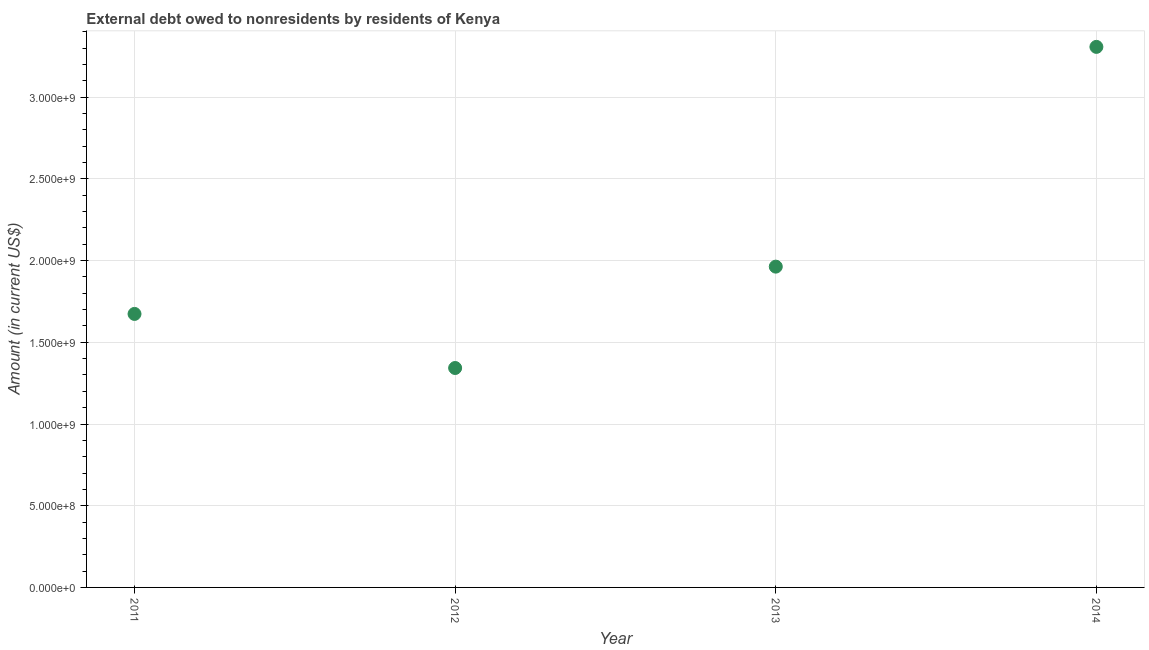What is the debt in 2011?
Your response must be concise. 1.67e+09. Across all years, what is the maximum debt?
Provide a short and direct response. 3.31e+09. Across all years, what is the minimum debt?
Your response must be concise. 1.34e+09. In which year was the debt minimum?
Provide a succinct answer. 2012. What is the sum of the debt?
Offer a terse response. 8.29e+09. What is the difference between the debt in 2011 and 2014?
Offer a very short reply. -1.63e+09. What is the average debt per year?
Your answer should be compact. 2.07e+09. What is the median debt?
Your answer should be very brief. 1.82e+09. In how many years, is the debt greater than 1400000000 US$?
Provide a short and direct response. 3. Do a majority of the years between 2011 and 2014 (inclusive) have debt greater than 3300000000 US$?
Your response must be concise. No. What is the ratio of the debt in 2011 to that in 2013?
Ensure brevity in your answer.  0.85. Is the debt in 2012 less than that in 2014?
Provide a short and direct response. Yes. What is the difference between the highest and the second highest debt?
Give a very brief answer. 1.34e+09. What is the difference between the highest and the lowest debt?
Your answer should be compact. 1.97e+09. In how many years, is the debt greater than the average debt taken over all years?
Your answer should be very brief. 1. What is the difference between two consecutive major ticks on the Y-axis?
Give a very brief answer. 5.00e+08. Are the values on the major ticks of Y-axis written in scientific E-notation?
Your response must be concise. Yes. Does the graph contain any zero values?
Provide a short and direct response. No. Does the graph contain grids?
Ensure brevity in your answer.  Yes. What is the title of the graph?
Keep it short and to the point. External debt owed to nonresidents by residents of Kenya. What is the label or title of the Y-axis?
Your answer should be very brief. Amount (in current US$). What is the Amount (in current US$) in 2011?
Offer a very short reply. 1.67e+09. What is the Amount (in current US$) in 2012?
Offer a terse response. 1.34e+09. What is the Amount (in current US$) in 2013?
Keep it short and to the point. 1.96e+09. What is the Amount (in current US$) in 2014?
Ensure brevity in your answer.  3.31e+09. What is the difference between the Amount (in current US$) in 2011 and 2012?
Offer a terse response. 3.31e+08. What is the difference between the Amount (in current US$) in 2011 and 2013?
Keep it short and to the point. -2.89e+08. What is the difference between the Amount (in current US$) in 2011 and 2014?
Your response must be concise. -1.63e+09. What is the difference between the Amount (in current US$) in 2012 and 2013?
Make the answer very short. -6.20e+08. What is the difference between the Amount (in current US$) in 2012 and 2014?
Make the answer very short. -1.97e+09. What is the difference between the Amount (in current US$) in 2013 and 2014?
Provide a succinct answer. -1.34e+09. What is the ratio of the Amount (in current US$) in 2011 to that in 2012?
Give a very brief answer. 1.25. What is the ratio of the Amount (in current US$) in 2011 to that in 2013?
Your response must be concise. 0.85. What is the ratio of the Amount (in current US$) in 2011 to that in 2014?
Offer a very short reply. 0.51. What is the ratio of the Amount (in current US$) in 2012 to that in 2013?
Your answer should be compact. 0.68. What is the ratio of the Amount (in current US$) in 2012 to that in 2014?
Ensure brevity in your answer.  0.41. What is the ratio of the Amount (in current US$) in 2013 to that in 2014?
Offer a very short reply. 0.59. 